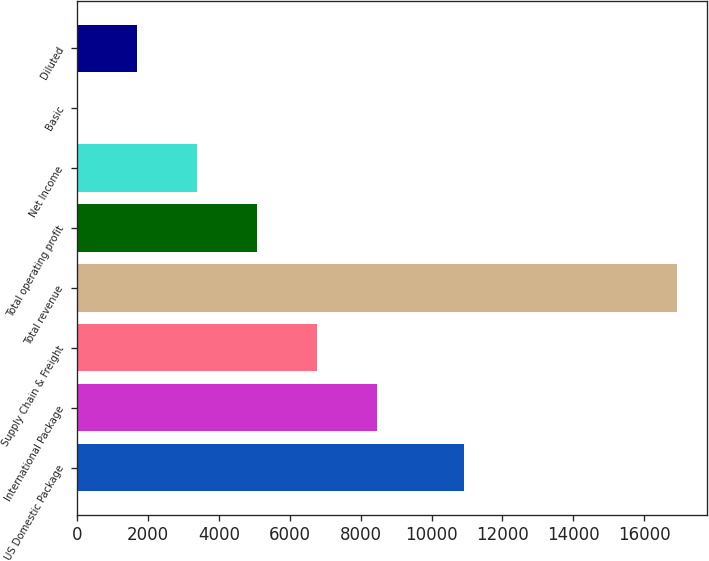<chart> <loc_0><loc_0><loc_500><loc_500><bar_chart><fcel>US Domestic Package<fcel>International Package<fcel>Supply Chain & Freight<fcel>Total revenue<fcel>Total operating profit<fcel>Net Income<fcel>Basic<fcel>Diluted<nl><fcel>10913<fcel>8465.62<fcel>6772.55<fcel>16931<fcel>5079.48<fcel>3386.41<fcel>0.27<fcel>1693.34<nl></chart> 